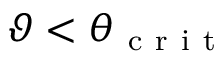<formula> <loc_0><loc_0><loc_500><loc_500>\vartheta < \theta _ { c r i t }</formula> 